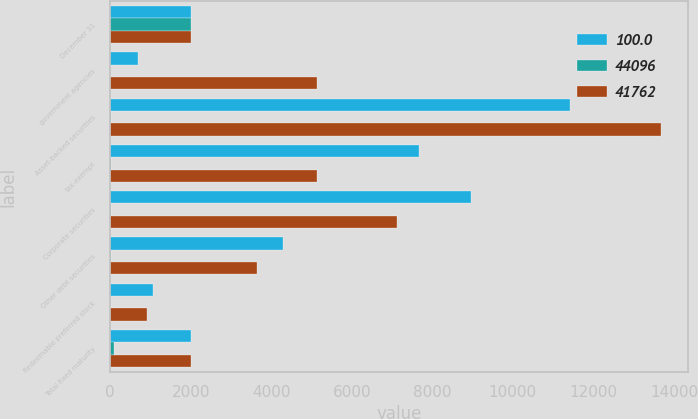Convert chart to OTSL. <chart><loc_0><loc_0><loc_500><loc_500><stacked_bar_chart><ecel><fcel>December 31<fcel>government agencies<fcel>Asset-backed securities<fcel>tax-exempt<fcel>Corporate securities<fcel>Other debt securities<fcel>Redeemable preferred stock<fcel>Total fixed maturity<nl><fcel>100<fcel>2007<fcel>687<fcel>11409<fcel>7675<fcel>8952<fcel>4299<fcel>1058<fcel>2006.5<nl><fcel>44096<fcel>2007<fcel>1.7<fcel>27.3<fcel>18.4<fcel>21.4<fcel>10.3<fcel>2.5<fcel>81.6<nl><fcel>41762<fcel>2006<fcel>5138<fcel>13677<fcel>5146<fcel>7132<fcel>3642<fcel>912<fcel>2006.5<nl></chart> 